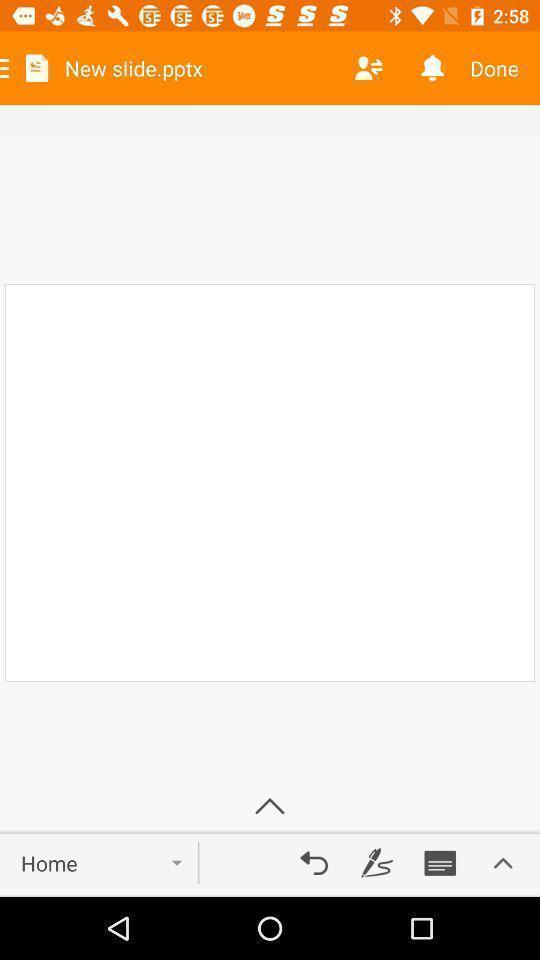Describe the content in this image. Screen displaying new slide page. 